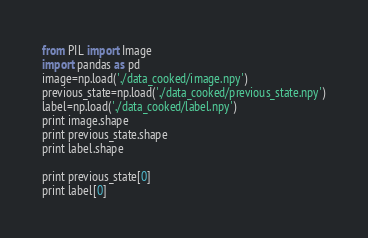Convert code to text. <code><loc_0><loc_0><loc_500><loc_500><_Python_>from PIL import Image
import pandas as pd
image=np.load('./data_cooked/image.npy')
previous_state=np.load('./data_cooked/previous_state.npy')
label=np.load('./data_cooked/label.npy')
print image.shape
print previous_state.shape
print label.shape

print previous_state[0]
print label[0]
</code> 